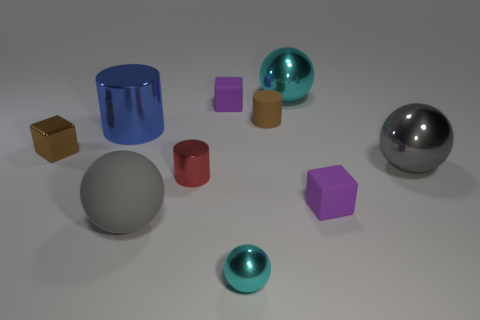The gray metal thing has what size?
Provide a succinct answer. Large. Are there any other things that have the same material as the red thing?
Offer a terse response. Yes. Are there any blocks that are behind the big gray ball that is behind the big sphere to the left of the tiny cyan metallic ball?
Offer a very short reply. Yes. What number of tiny objects are blue matte cubes or purple rubber things?
Keep it short and to the point. 2. Is there anything else that has the same color as the rubber sphere?
Make the answer very short. Yes. There is a ball in front of the matte ball; is it the same size as the large blue object?
Offer a terse response. No. The shiny object behind the purple rubber object behind the tiny purple rubber cube that is on the right side of the tiny metallic sphere is what color?
Provide a short and direct response. Cyan. The tiny metallic cylinder is what color?
Your answer should be compact. Red. Do the tiny shiny sphere and the large rubber object have the same color?
Provide a short and direct response. No. Does the small purple cube in front of the gray metal ball have the same material as the big sphere that is behind the large shiny cylinder?
Make the answer very short. No. 